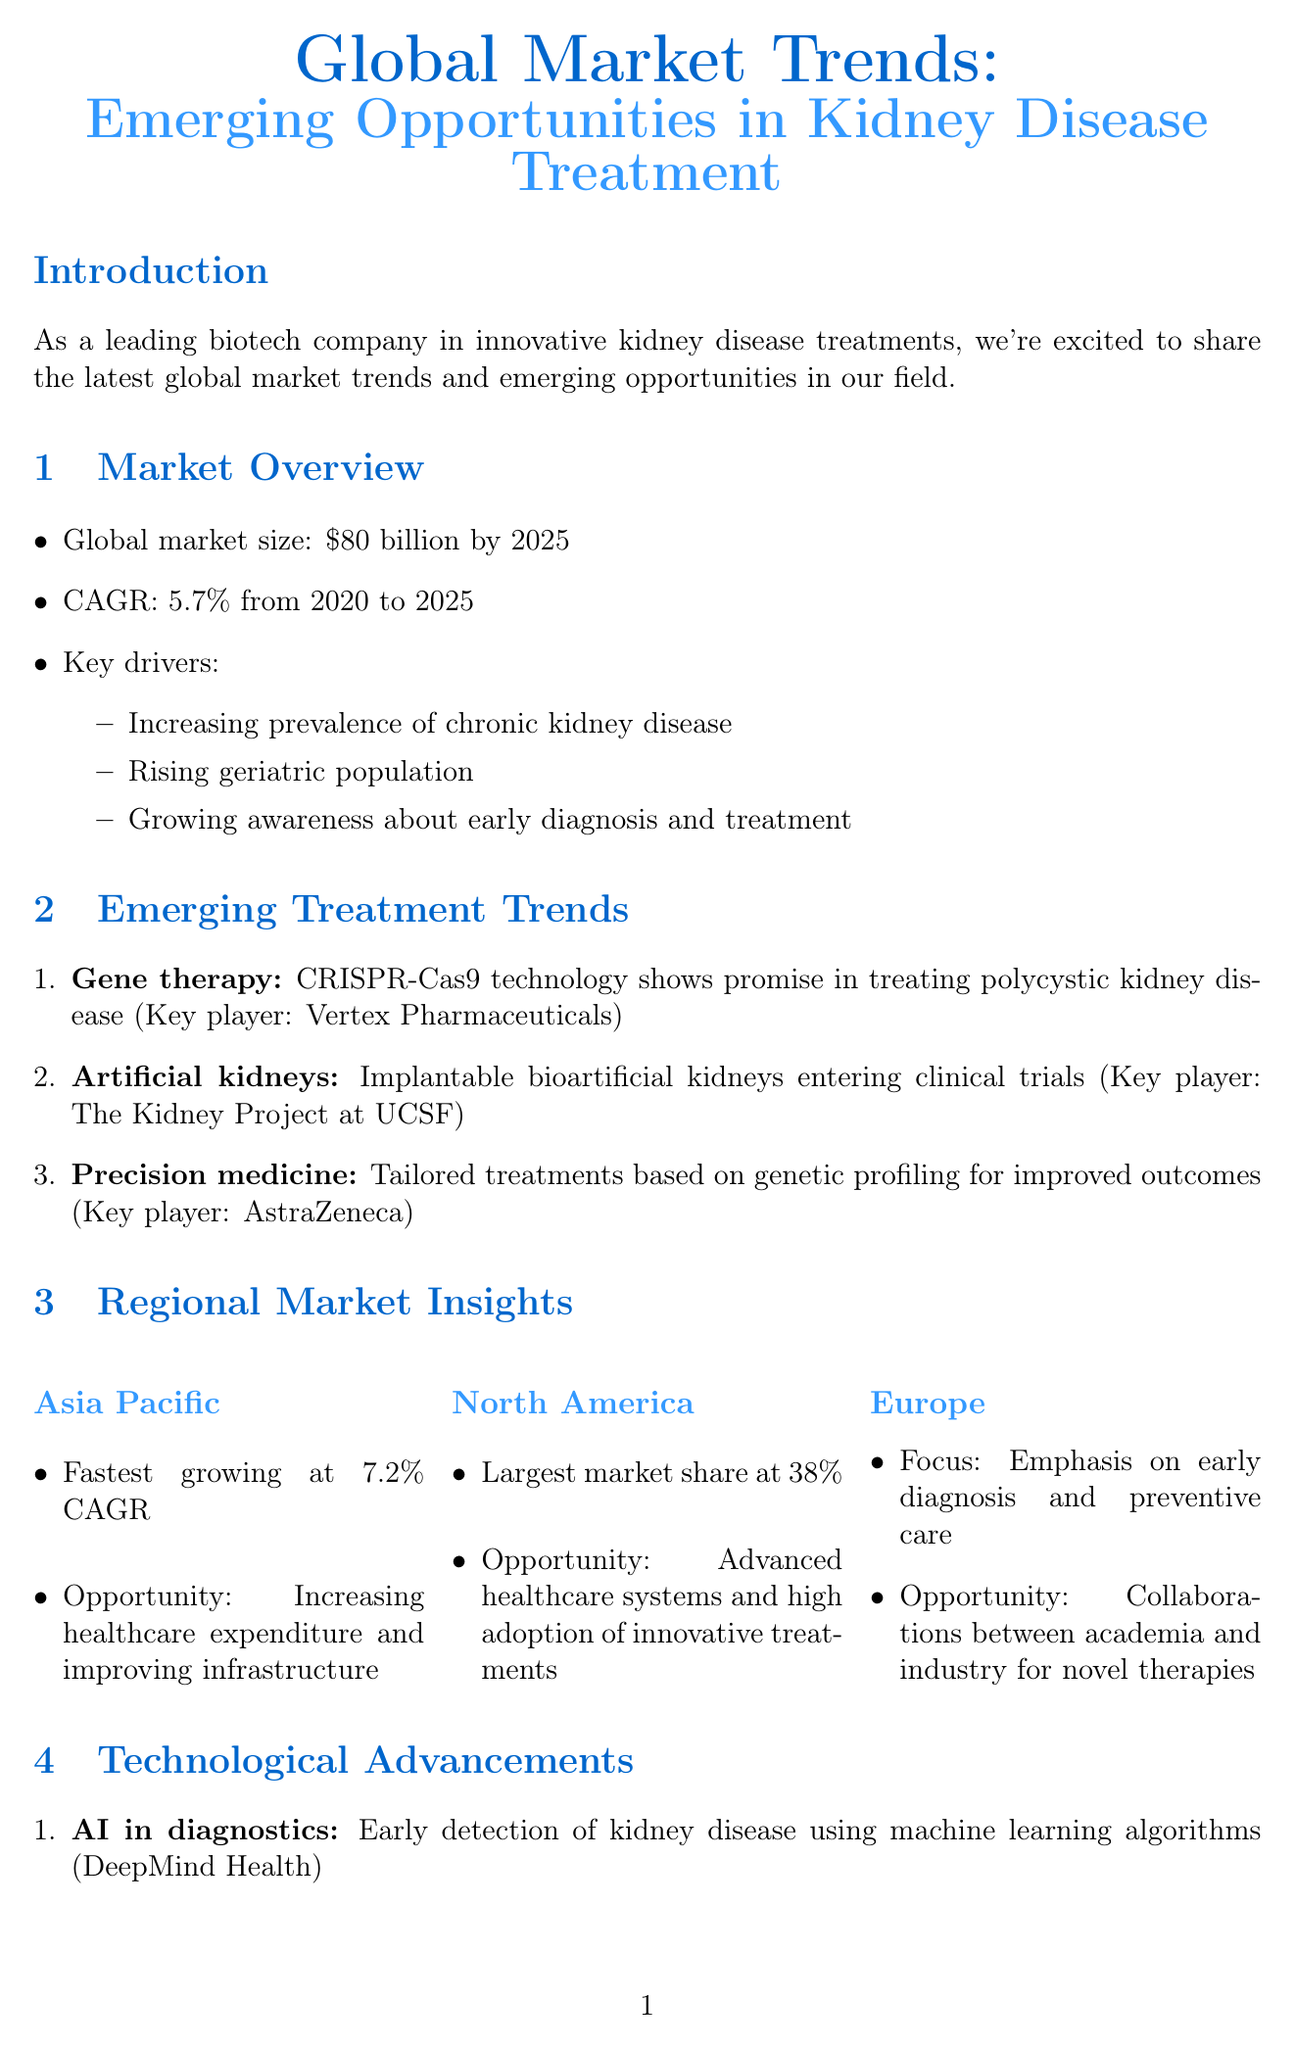what is the global market size for kidney disease treatment by 2025? The document states that the global market size is expected to reach $80 billion by 2025.
Answer: $80 billion by 2025 what is the CAGR from 2020 to 2025 for the kidney disease treatment market? The document mentions that the CAGR is projected to be 5.7% from 2020 to 2025.
Answer: 5.7% which region has the fastest growth rate in the kidney disease treatment market? The document indicates that the Asia Pacific region has the fastest growing rate at 7.2% CAGR.
Answer: Asia Pacific who is the key player in gene therapy for kidney disease? The document lists Vertex Pharmaceuticals as the key player in gene therapy.
Answer: Vertex Pharmaceuticals what technology is used for early detection of kidney disease? The document mentions AI in diagnostics as the technology used for early detection.
Answer: AI in diagnostics what opportunity is highlighted for the North America region? The document states that the opportunity in North America is advanced healthcare systems and high adoption of innovative treatments.
Answer: Advanced healthcare systems and high adoption of innovative treatments which company is involved in creating wearable dialysis devices? The document names Fresenius Medical Care as the company involved in this technology.
Answer: Fresenius Medical Care what regulatory incentive exists for rare kidney disorders in the EU? The document mentions the EU Orphan Drug Designation as an incentive for developing treatments for rare kidney disorders.
Answer: EU Orphan Drug Designation what is emphasized in Europe regarding kidney disease treatment? The document emphasizes the focus on early diagnosis and preventive care in Europe.
Answer: Early diagnosis and preventive care 